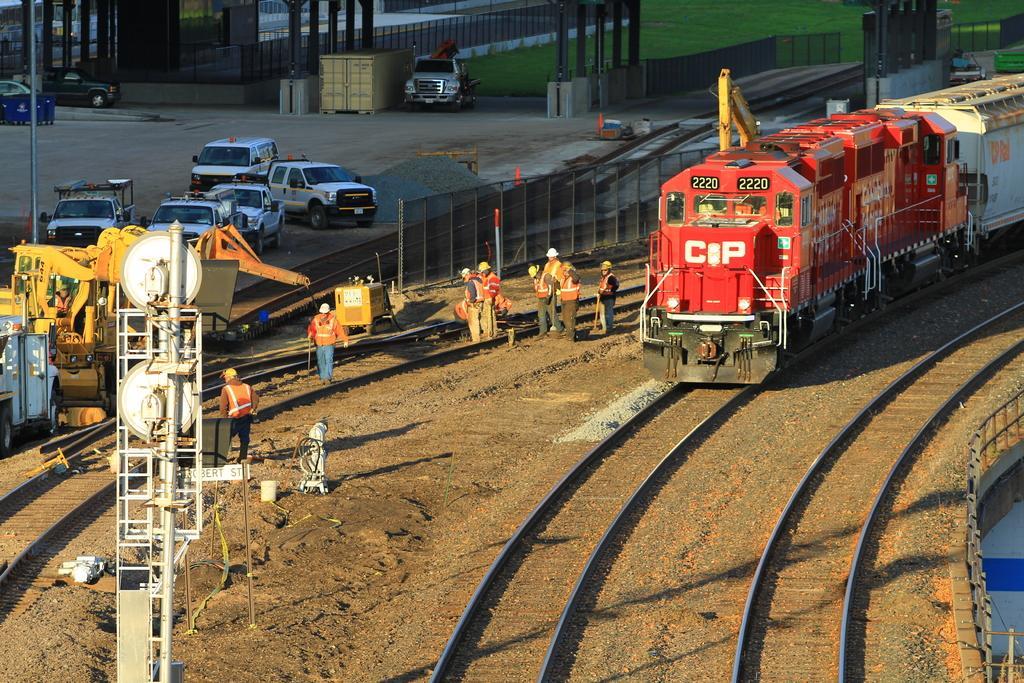How would you summarize this image in a sentence or two? In the center of the image we can see some persons, vehicle, machine, mesh, poles. On the right side of the image we can see train, railway track, bridge. On the left side of the image we can see some vehicles. At the top of the image we can see ground, poles, vehicles, road. 